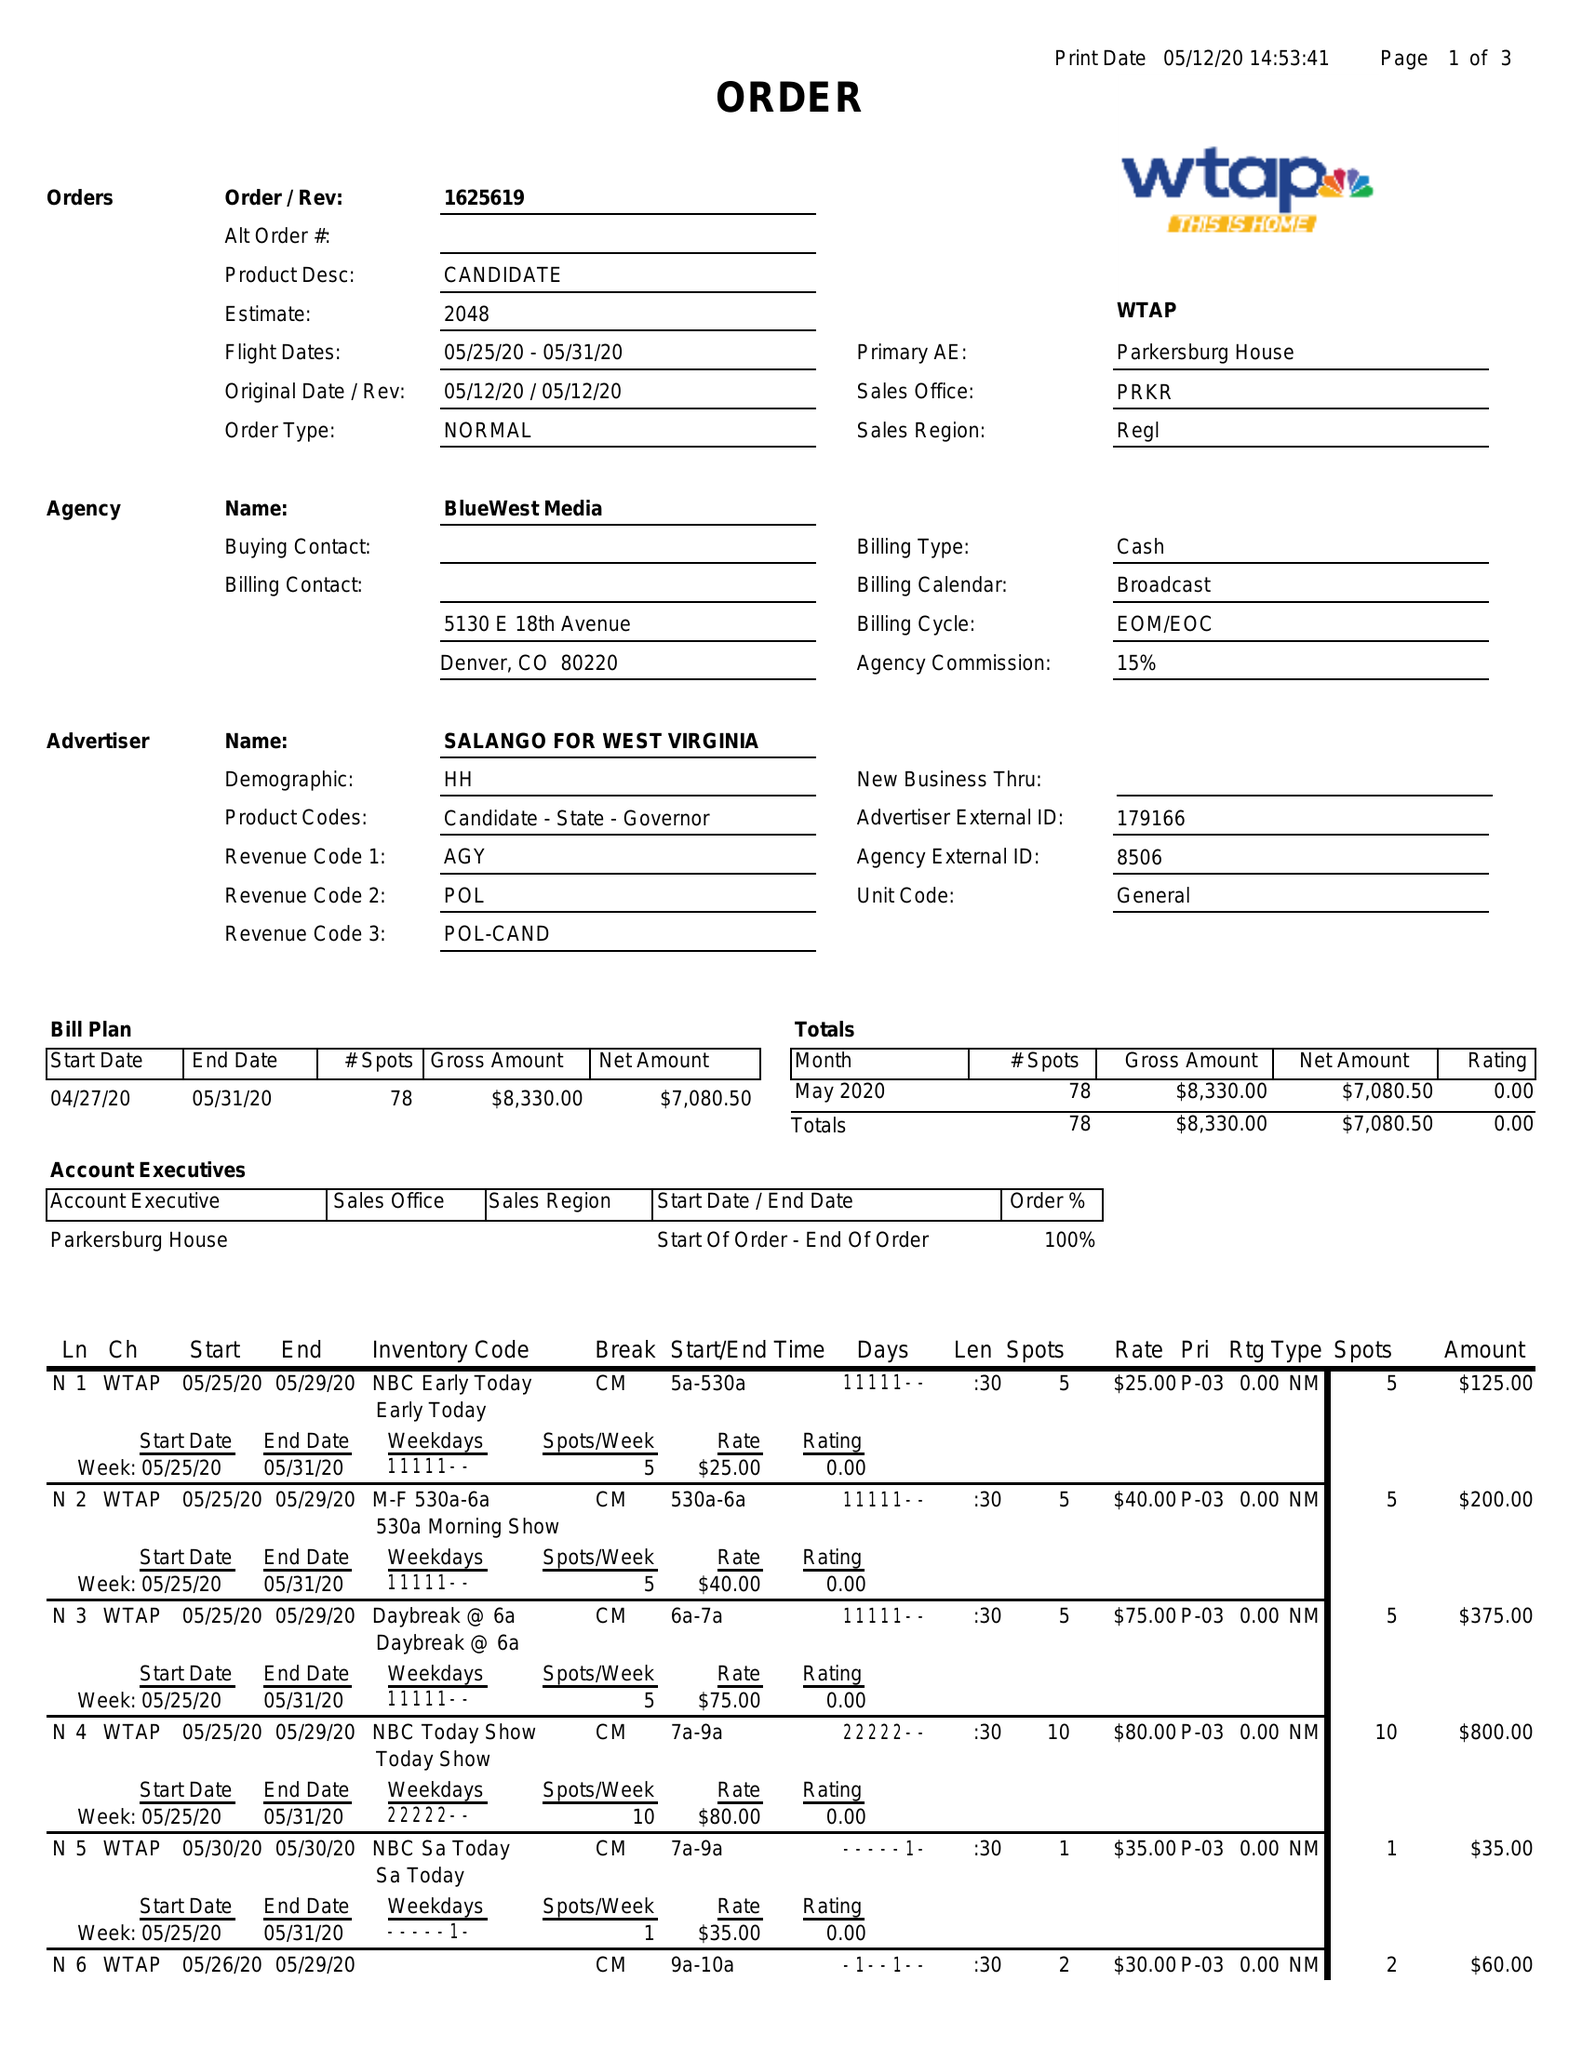What is the value for the flight_from?
Answer the question using a single word or phrase. 05/25/20 